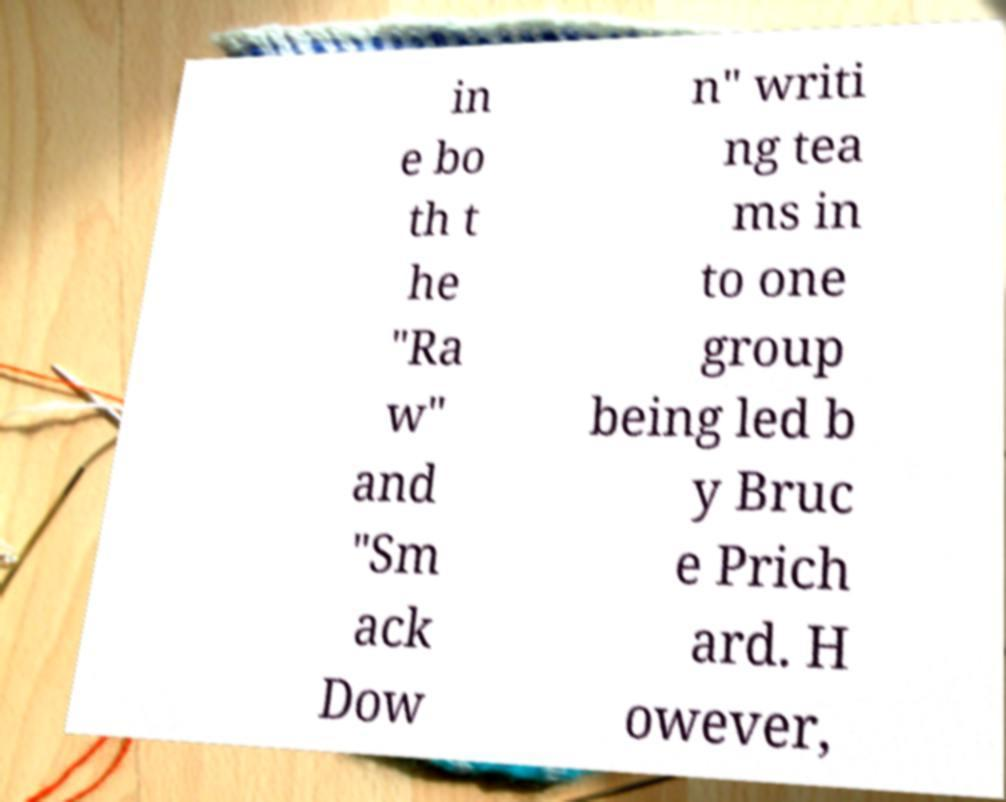Please identify and transcribe the text found in this image. in e bo th t he "Ra w" and "Sm ack Dow n" writi ng tea ms in to one group being led b y Bruc e Prich ard. H owever, 